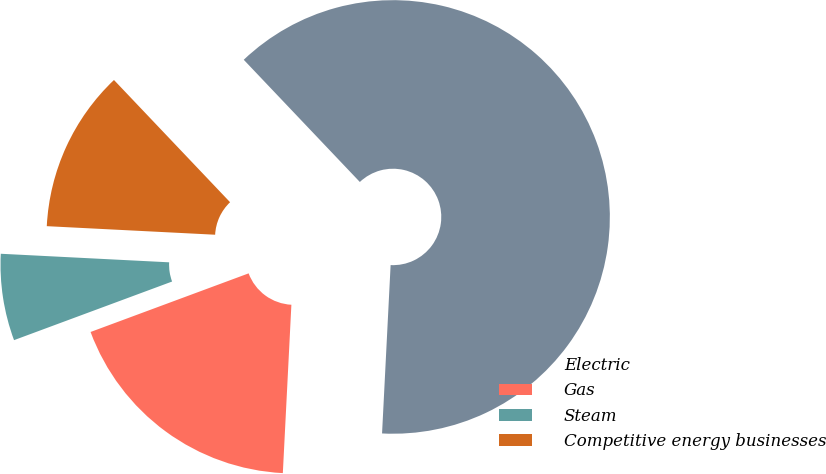Convert chart. <chart><loc_0><loc_0><loc_500><loc_500><pie_chart><fcel>Electric<fcel>Gas<fcel>Steam<fcel>Competitive energy businesses<nl><fcel>62.9%<fcel>18.54%<fcel>6.46%<fcel>12.1%<nl></chart> 